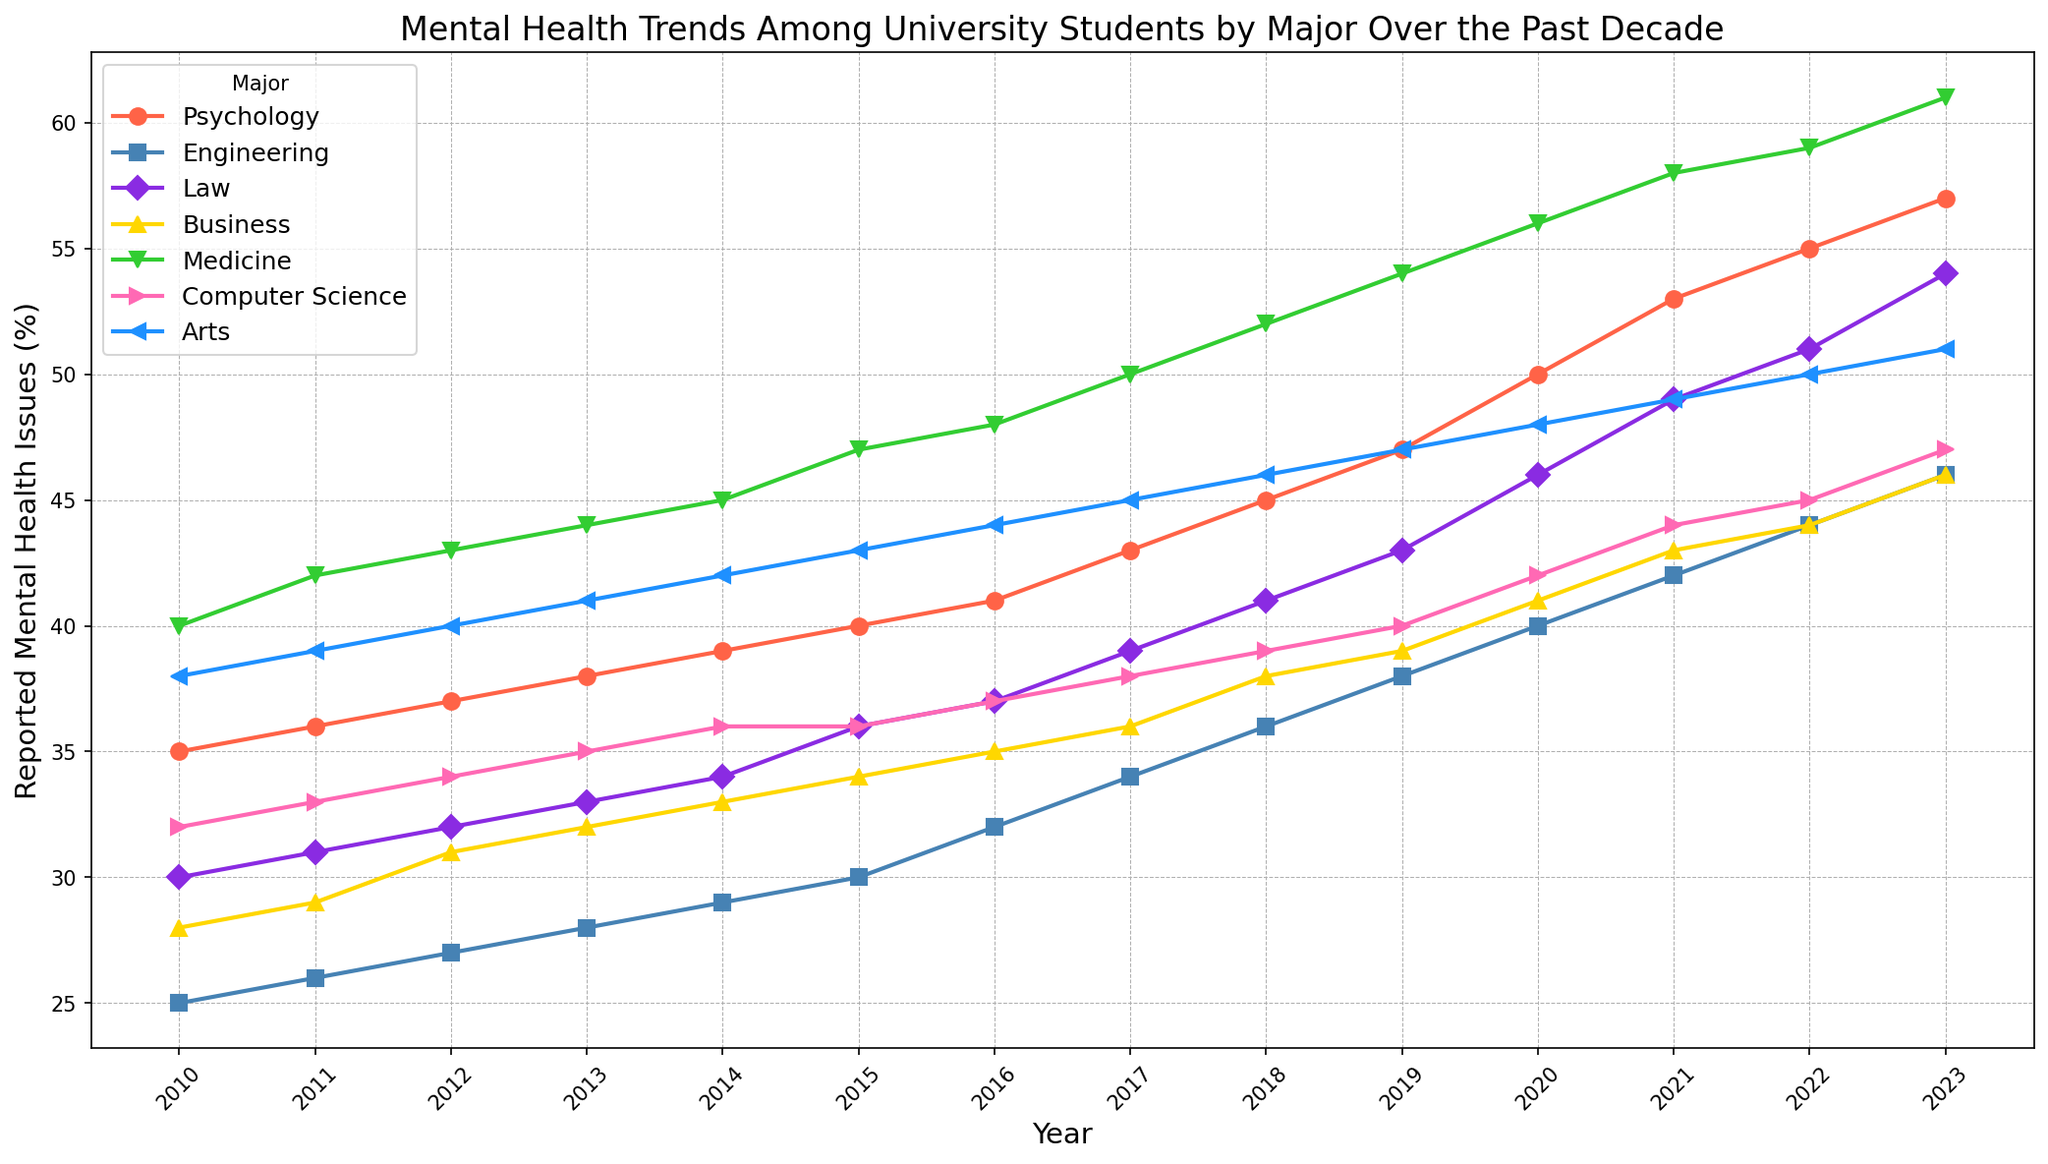What's the general trend for mental health issues among law students over the past decade? To find the trend in mental health issues among law students, observe the line that represents law students from 2010 to 2023. Starting from around 30% in 2010, there is a steady increase each year reaching about 54% in 2023.
Answer: Increasing Which major showed the highest percentage of reported mental health issues in 2023? Look at the line chart and identify the highest value in 2023. The major corresponding to this high value, shown around 61%, is Medicine.
Answer: Medicine How did the percentage of reported mental health issues in Business majors in 2015 compare to 2019? Locate the points for Business majors in 2015 and 2019. In 2015, it's around 34%, and in 2019, it's around 39%. Comparing these, 39% in 2019 is higher than 34% in 2015.
Answer: 2019 had higher values What is the average percentage of reported mental health issues for Computer Science majors from 2010 to 2023? First, sum the values for Computer Science majors from 2010 (32) to 2023 (47), which equals 540. There are 14 years of data, so divide 540 by 14 to find the average. (540/14)
Answer: 38.57 Which two majors had similar percentages of reported mental health issues in 2011, and what were those percentages? Compare the values for different majors in 2011. Both Law and Business majors had around 31%, which are close to each other.
Answer: Law and Business, 31% What is the difference in the percentage of mental health issues between Psychology and Engineering majors in 2020? In 2020, Psychology is at 50%, and Engineering is at 40%. Subtract the two values to get the difference (50 - 40).
Answer: 10% Which major showed the most consistent increase in mental health issues over the years? Analyze the lines to identify which major has the most regular and consistent upward trend without significant fluctuations. Psychology shows a steady and consistent increase from 35% in 2010 to 57% in 2023.
Answer: Psychology How does the mental health issue trend for Arts compare to Medicine in terms of steepness over the last decade? By visually comparing the slopes of the lines for Arts and Medicine from 2010 to 2023, observe that Medicine shows a steeper increase, rising from 40% to 61%, while Arts increases more gradually from 38% to 51%.
Answer: Medicine is steeper What was the rate of increase in reported mental health issues for Engineering majors between 2016 and 2023? Note the values for Engineering in 2016 and 2023, which are 32% and 46% respectively. The rate of increase is the change divided by the number of years (46-32)/(2023-2016) = 14/7 = 2% per year.
Answer: 2% per year 